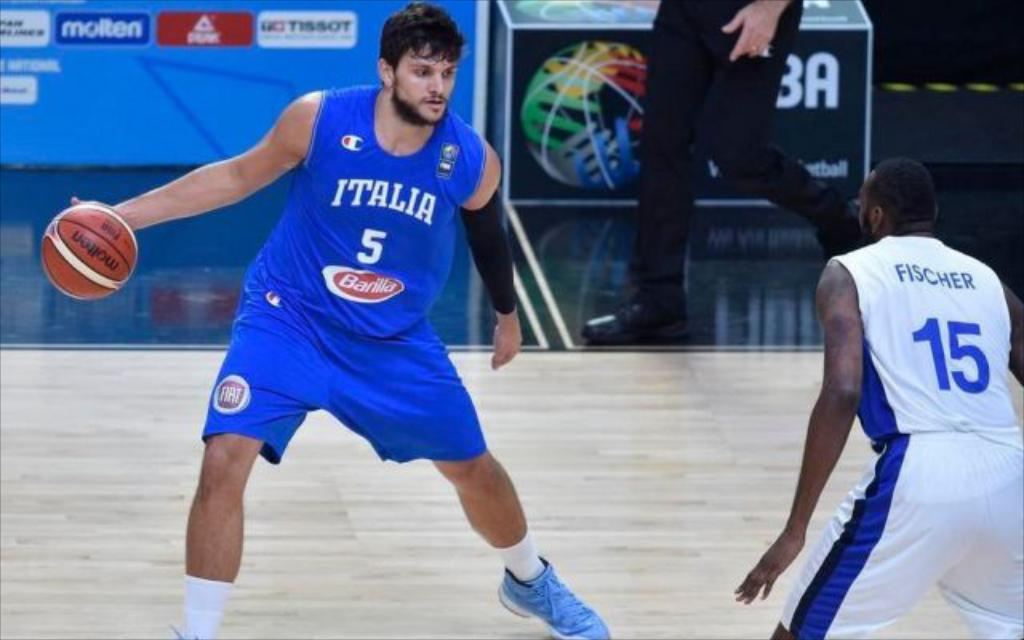<image>
Share a concise interpretation of the image provided. Two basketball players competing in a match and one player belongs to team Italy. 